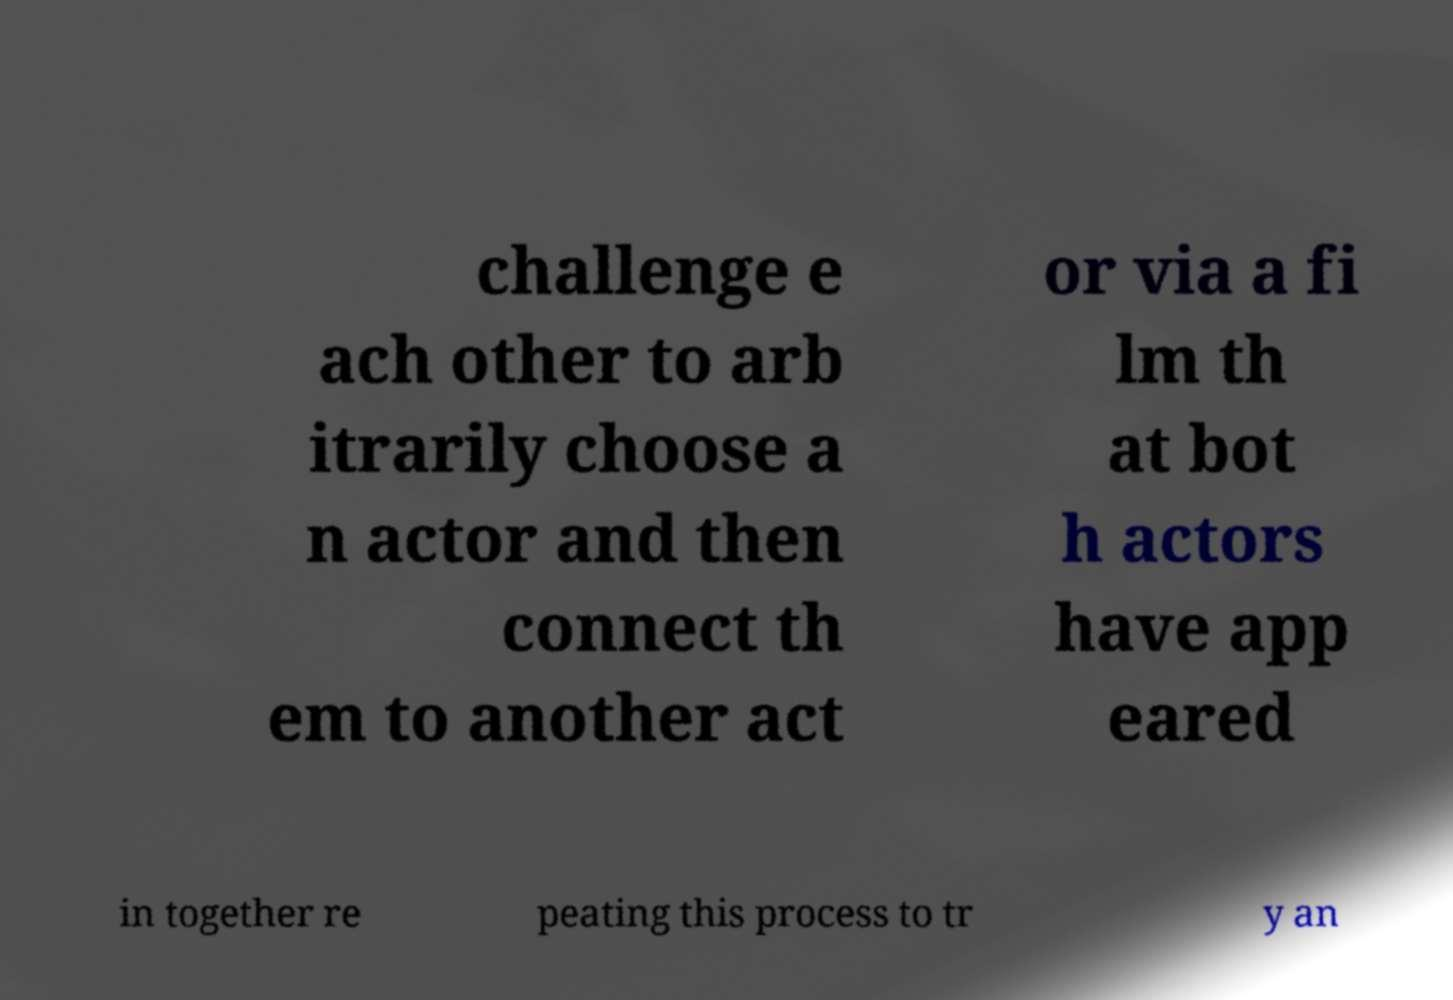Please identify and transcribe the text found in this image. challenge e ach other to arb itrarily choose a n actor and then connect th em to another act or via a fi lm th at bot h actors have app eared in together re peating this process to tr y an 